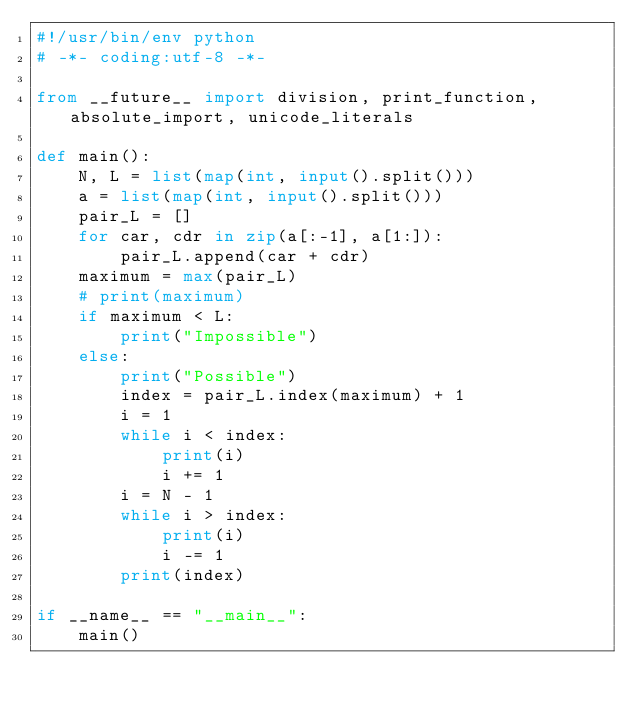Convert code to text. <code><loc_0><loc_0><loc_500><loc_500><_Python_>#!/usr/bin/env python
# -*- coding:utf-8 -*-

from __future__ import division, print_function, absolute_import, unicode_literals

def main():
    N, L = list(map(int, input().split()))
    a = list(map(int, input().split()))
    pair_L = []
    for car, cdr in zip(a[:-1], a[1:]):
        pair_L.append(car + cdr)
    maximum = max(pair_L)
    # print(maximum)
    if maximum < L:
        print("Impossible")
    else:
        print("Possible")
        index = pair_L.index(maximum) + 1
        i = 1
        while i < index:
            print(i)
            i += 1
        i = N - 1
        while i > index:
            print(i)
            i -= 1
        print(index)

if __name__ == "__main__":
    main()
</code> 